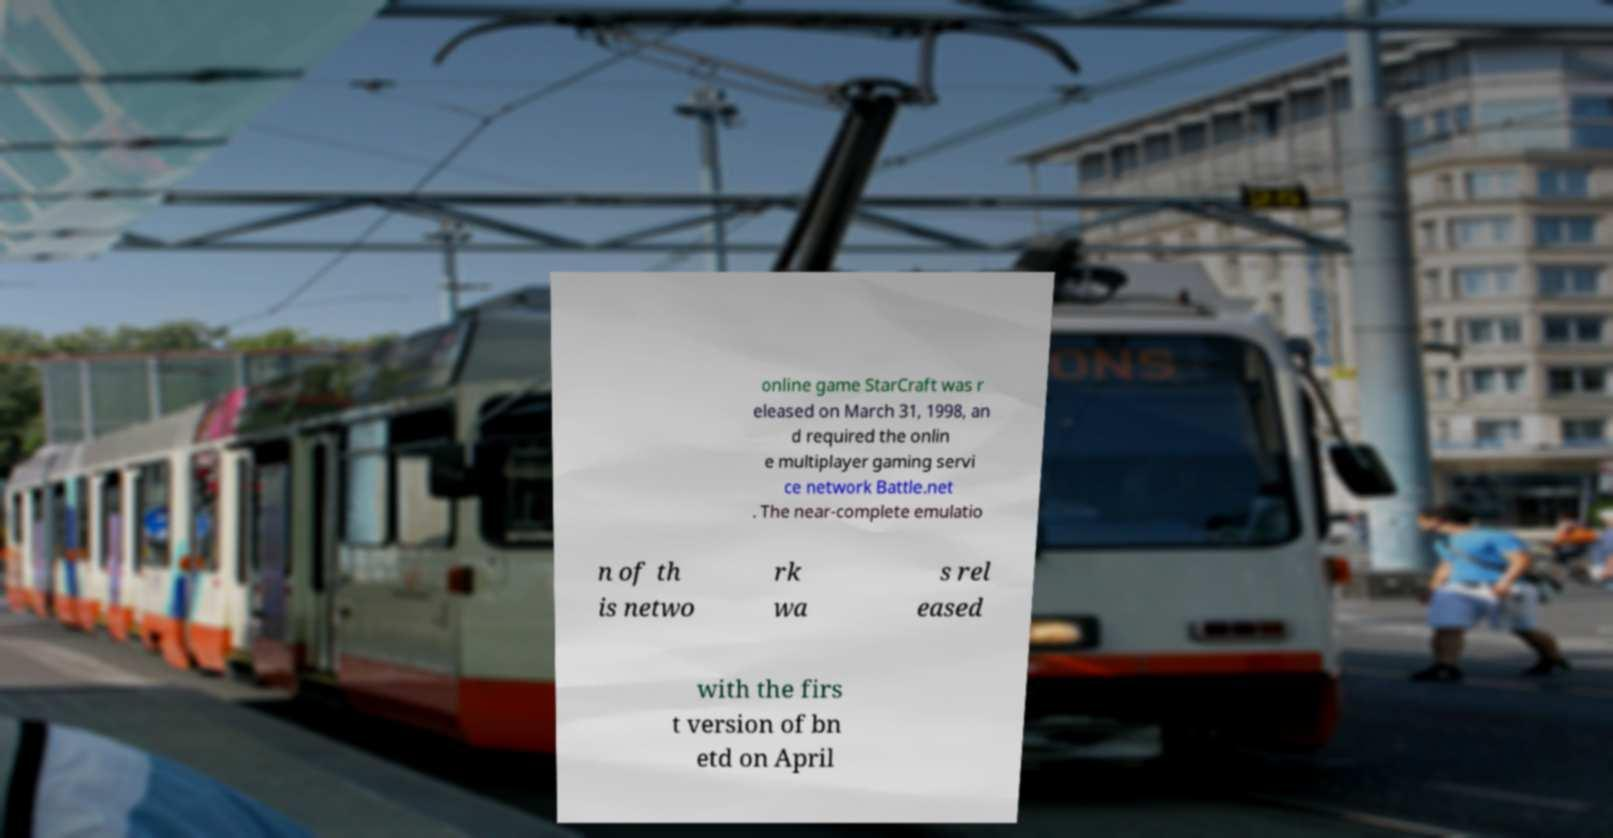Can you accurately transcribe the text from the provided image for me? online game StarCraft was r eleased on March 31, 1998, an d required the onlin e multiplayer gaming servi ce network Battle.net . The near-complete emulatio n of th is netwo rk wa s rel eased with the firs t version of bn etd on April 